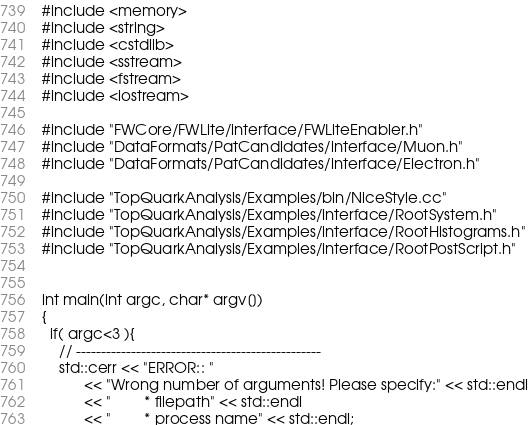Convert code to text. <code><loc_0><loc_0><loc_500><loc_500><_C++_>#include <memory>
#include <string>
#include <cstdlib>
#include <sstream>
#include <fstream>
#include <iostream>

#include "FWCore/FWLite/interface/FWLiteEnabler.h"
#include "DataFormats/PatCandidates/interface/Muon.h"
#include "DataFormats/PatCandidates/interface/Electron.h"

#include "TopQuarkAnalysis/Examples/bin/NiceStyle.cc"
#include "TopQuarkAnalysis/Examples/interface/RootSystem.h"
#include "TopQuarkAnalysis/Examples/interface/RootHistograms.h"
#include "TopQuarkAnalysis/Examples/interface/RootPostScript.h"


int main(int argc, char* argv[]) 
{
  if( argc<3 ){
    // ------------------------------------------------- 
    std::cerr << "ERROR:: " 
	      << "Wrong number of arguments! Please specify:" << std::endl
	      << "        * filepath" << std::endl
	      << "        * process name" << std::endl; </code> 